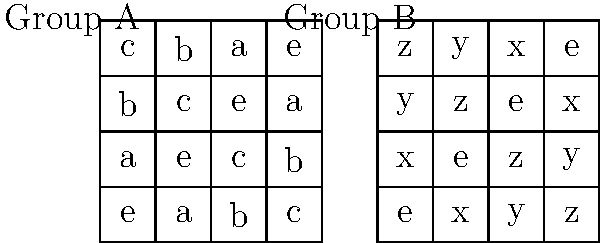As a software engineer working on a techno-thriller novel involving cryptographic systems based on group theory, you encounter two groups with their multiplication tables shown above. Are these groups isomorphic? Justify your answer using the properties of group isomorphisms. To determine if the groups are isomorphic, we need to follow these steps:

1. Check if both groups have the same order (number of elements):
   Both Group A and Group B have 4 elements, so this condition is satisfied.

2. Identify the identity elements:
   In Group A, 'e' is the identity.
   In Group B, 'e' is also the identity.

3. Find elements of order 2 (elements that square to the identity):
   In Group A: $a^2 = e$, $b^2 = e$, $c^2 = e$
   In Group B: $x^2 = e$, $y^2 = e$, $z^2 = e$

4. Check the overall structure:
   Both groups have one identity element and three elements of order 2.
   This structure is consistent with the Klein four-group ($V_4$).

5. Verify that the groups are abelian (commutative):
   Both tables are symmetric about the main diagonal, indicating commutativity.

6. Construct an isomorphism:
   We can define a bijective homomorphism $\phi: A \to B$ as follows:
   $\phi(e) = e$
   $\phi(a) = x$
   $\phi(b) = y$
   $\phi(c) = z$

7. Verify that $\phi$ preserves the group operation:
   For example, $\phi(a \cdot b) = \phi(c) = z = x \cdot y = \phi(a) \cdot \phi(b)$
   This holds for all combinations of elements.

Since we have found a bijective homomorphism that preserves the group operation, we can conclude that the groups are isomorphic.
Answer: Yes, the groups are isomorphic. 